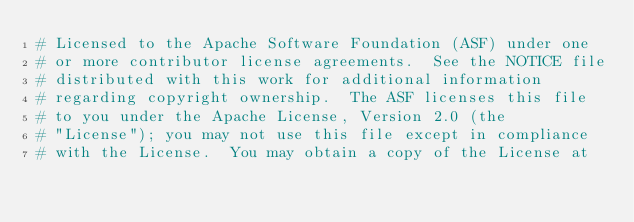<code> <loc_0><loc_0><loc_500><loc_500><_Python_># Licensed to the Apache Software Foundation (ASF) under one
# or more contributor license agreements.  See the NOTICE file
# distributed with this work for additional information
# regarding copyright ownership.  The ASF licenses this file
# to you under the Apache License, Version 2.0 (the
# "License"); you may not use this file except in compliance
# with the License.  You may obtain a copy of the License at</code> 